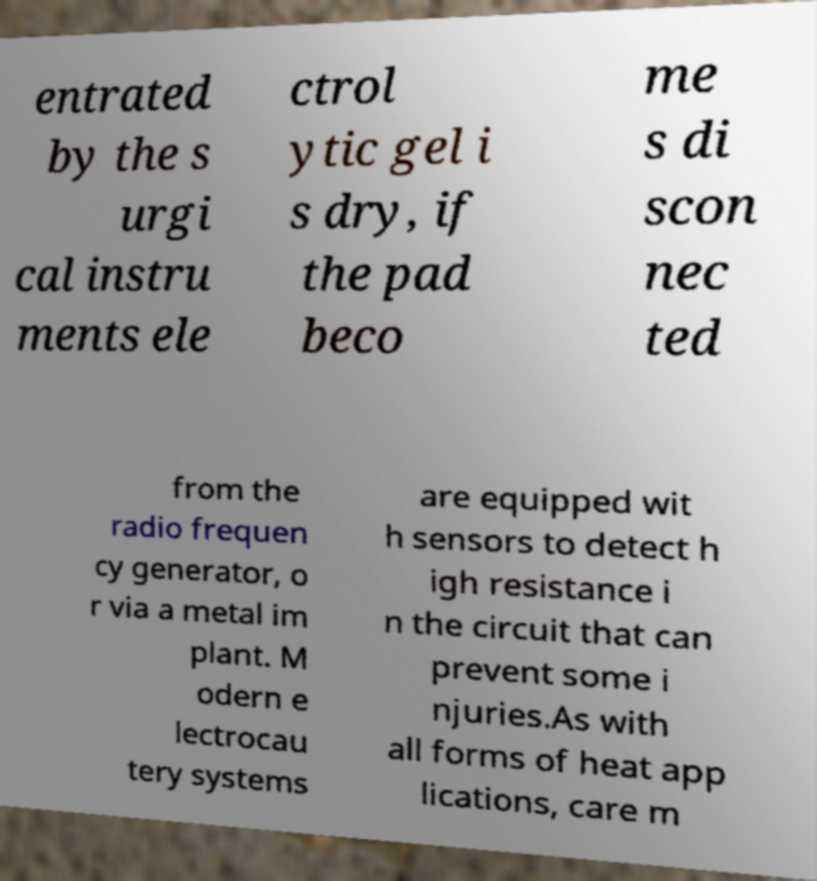Could you extract and type out the text from this image? entrated by the s urgi cal instru ments ele ctrol ytic gel i s dry, if the pad beco me s di scon nec ted from the radio frequen cy generator, o r via a metal im plant. M odern e lectrocau tery systems are equipped wit h sensors to detect h igh resistance i n the circuit that can prevent some i njuries.As with all forms of heat app lications, care m 